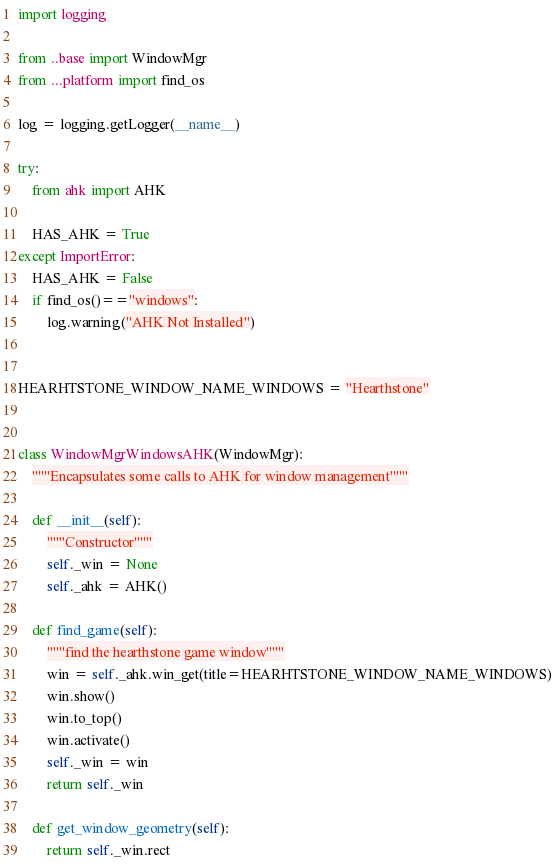<code> <loc_0><loc_0><loc_500><loc_500><_Python_>import logging

from ..base import WindowMgr
from ...platform import find_os

log = logging.getLogger(__name__)

try:
    from ahk import AHK

    HAS_AHK = True
except ImportError:
    HAS_AHK = False
    if find_os()=="windows":
        log.warning("AHK Not Installed")


HEARHTSTONE_WINDOW_NAME_WINDOWS = "Hearthstone"


class WindowMgrWindowsAHK(WindowMgr):
    """Encapsulates some calls to AHK for window management"""

    def __init__(self):
        """Constructor"""
        self._win = None
        self._ahk = AHK()

    def find_game(self):
        """find the hearthstone game window"""
        win = self._ahk.win_get(title=HEARHTSTONE_WINDOW_NAME_WINDOWS)
        win.show()
        win.to_top()
        win.activate()
        self._win = win
        return self._win

    def get_window_geometry(self):
        return self._win.rect
</code> 